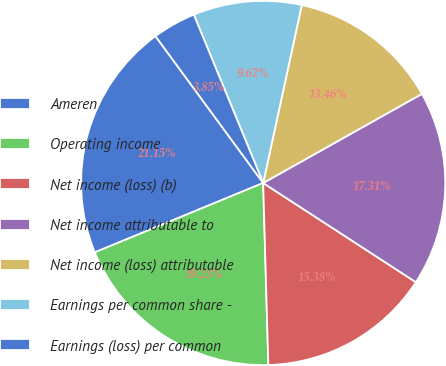Convert chart. <chart><loc_0><loc_0><loc_500><loc_500><pie_chart><fcel>Ameren<fcel>Operating income<fcel>Net income (loss) (b)<fcel>Net income attributable to<fcel>Net income (loss) attributable<fcel>Earnings per common share -<fcel>Earnings (loss) per common<nl><fcel>21.15%<fcel>19.23%<fcel>15.38%<fcel>17.31%<fcel>13.46%<fcel>9.62%<fcel>3.85%<nl></chart> 